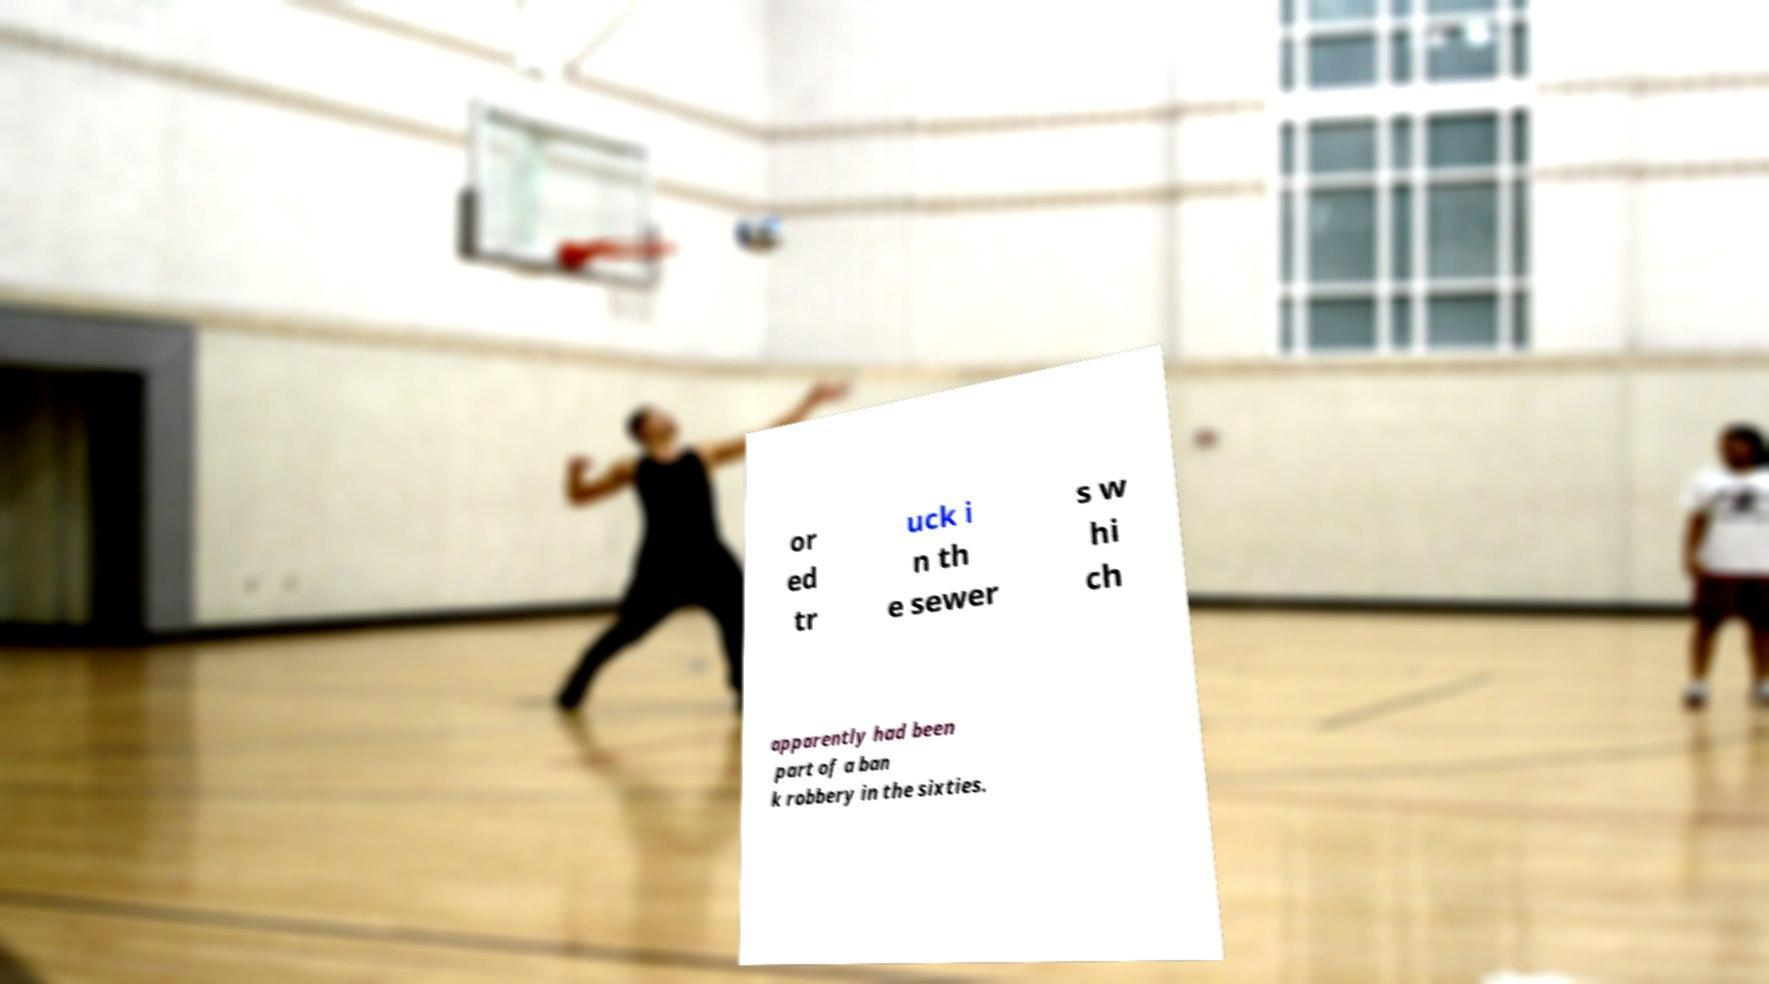For documentation purposes, I need the text within this image transcribed. Could you provide that? or ed tr uck i n th e sewer s w hi ch apparently had been part of a ban k robbery in the sixties. 